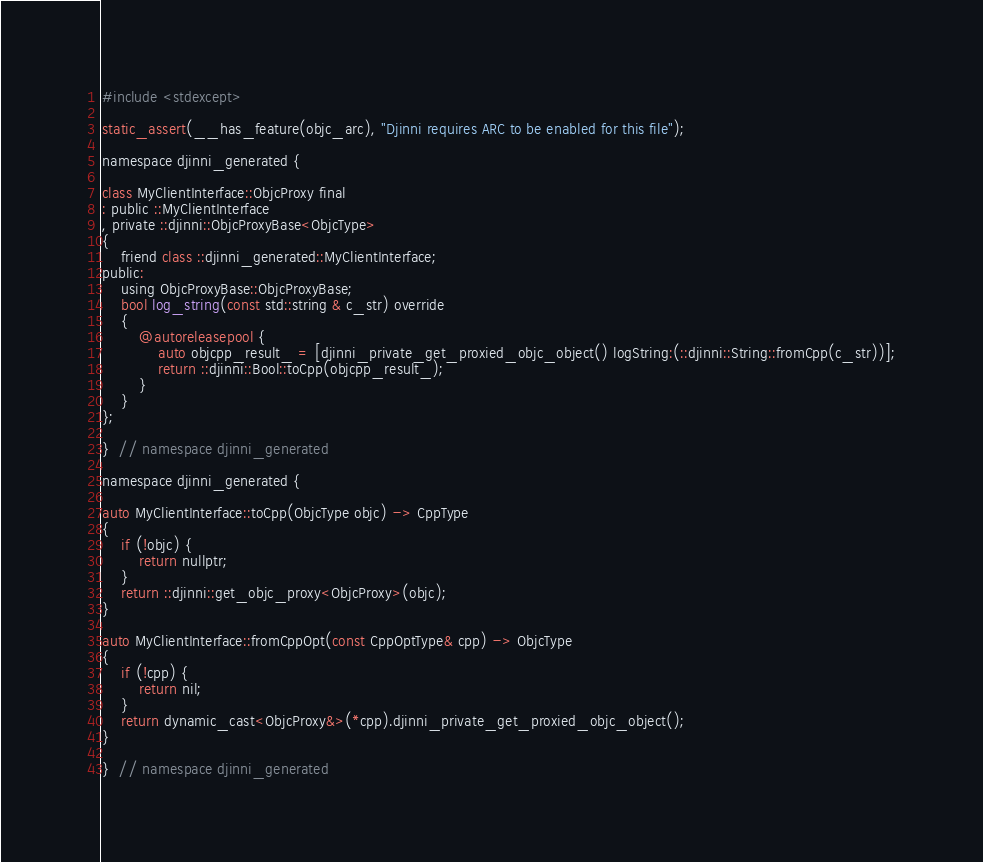<code> <loc_0><loc_0><loc_500><loc_500><_ObjectiveC_>#include <stdexcept>

static_assert(__has_feature(objc_arc), "Djinni requires ARC to be enabled for this file");

namespace djinni_generated {

class MyClientInterface::ObjcProxy final
: public ::MyClientInterface
, private ::djinni::ObjcProxyBase<ObjcType>
{
    friend class ::djinni_generated::MyClientInterface;
public:
    using ObjcProxyBase::ObjcProxyBase;
    bool log_string(const std::string & c_str) override
    {
        @autoreleasepool {
            auto objcpp_result_ = [djinni_private_get_proxied_objc_object() logString:(::djinni::String::fromCpp(c_str))];
            return ::djinni::Bool::toCpp(objcpp_result_);
        }
    }
};

}  // namespace djinni_generated

namespace djinni_generated {

auto MyClientInterface::toCpp(ObjcType objc) -> CppType
{
    if (!objc) {
        return nullptr;
    }
    return ::djinni::get_objc_proxy<ObjcProxy>(objc);
}

auto MyClientInterface::fromCppOpt(const CppOptType& cpp) -> ObjcType
{
    if (!cpp) {
        return nil;
    }
    return dynamic_cast<ObjcProxy&>(*cpp).djinni_private_get_proxied_objc_object();
}

}  // namespace djinni_generated
</code> 